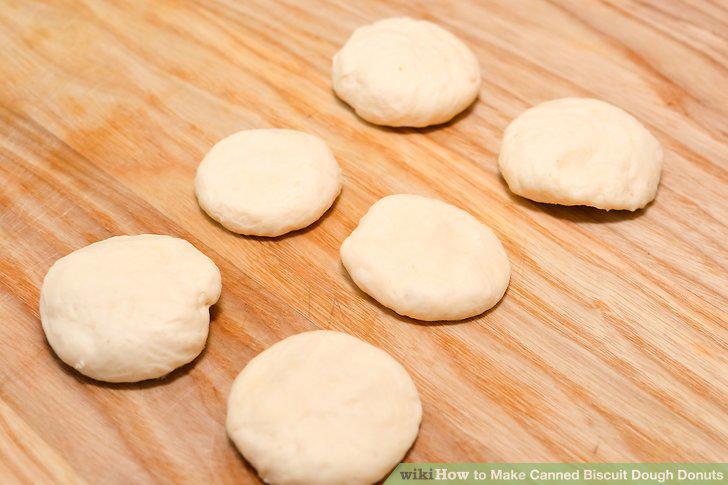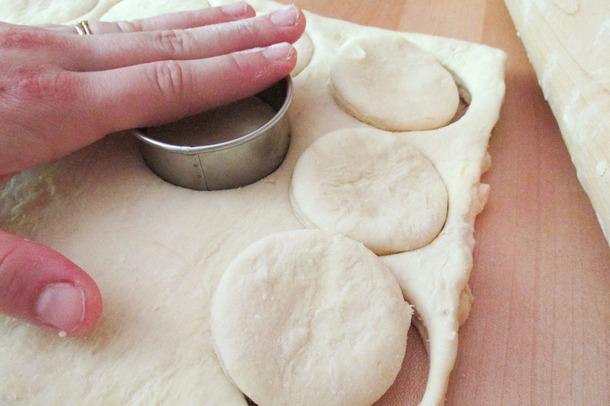The first image is the image on the left, the second image is the image on the right. Evaluate the accuracy of this statement regarding the images: "The dough in at least one image is still in a round biscuit can shape.". Is it true? Answer yes or no. No. The first image is the image on the left, the second image is the image on the right. Evaluate the accuracy of this statement regarding the images: "Some dough is shaped like a cylinder.". Is it true? Answer yes or no. No. 